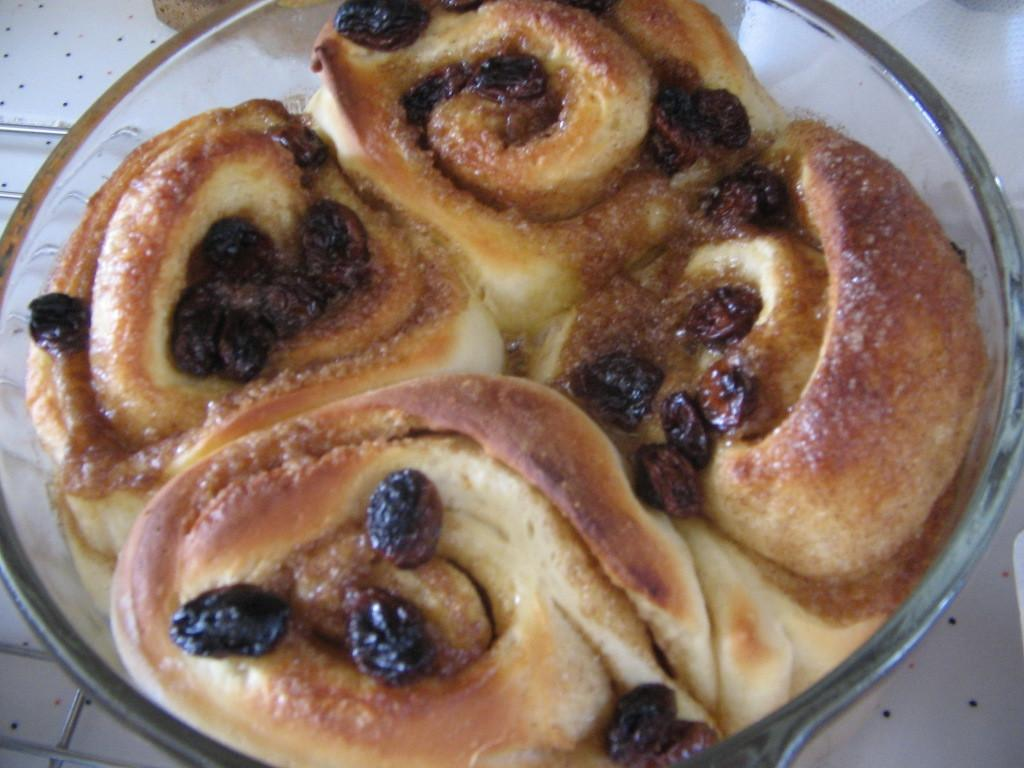What is in the bowl that is visible in the image? There is a food item in a bowl in the image. What is the bowl placed on? The bowl is on an object. What type of flower is growing in the bowl in the image? There is no flower present in the bowl in the image; it contains a food item. 